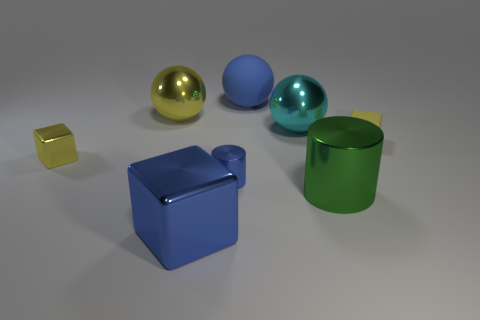Is the shape of the small rubber object that is in front of the large cyan shiny ball the same as the rubber object that is left of the green object?
Provide a succinct answer. No. What material is the cube that is the same size as the green metal cylinder?
Your answer should be compact. Metal. How many other things are made of the same material as the big green object?
Your answer should be very brief. 5. There is a small blue metallic object that is on the left side of the big cylinder that is behind the big cube; what is its shape?
Your answer should be compact. Cylinder. How many objects are tiny yellow shiny cylinders or yellow things that are on the right side of the big blue metal block?
Ensure brevity in your answer.  1. How many other objects are the same color as the small metallic cube?
Offer a very short reply. 2. What number of gray objects are either balls or big cylinders?
Offer a very short reply. 0. Is there a small yellow rubber block that is in front of the blue thing that is behind the shiny ball right of the big blue matte object?
Your answer should be compact. Yes. Is the color of the big matte ball the same as the large cube?
Give a very brief answer. Yes. There is a tiny metal thing that is in front of the yellow cube that is to the left of the large blue metallic thing; what color is it?
Keep it short and to the point. Blue. 